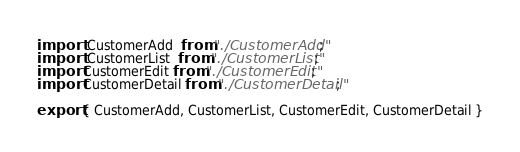Convert code to text. <code><loc_0><loc_0><loc_500><loc_500><_JavaScript_>import  CustomerAdd  from "./CustomerAdd";
import  CustomerList  from "./CustomerList";
import CustomerEdit from "./CustomerEdit";
import CustomerDetail from "./CustomerDetail";

export { CustomerAdd, CustomerList, CustomerEdit, CustomerDetail }</code> 